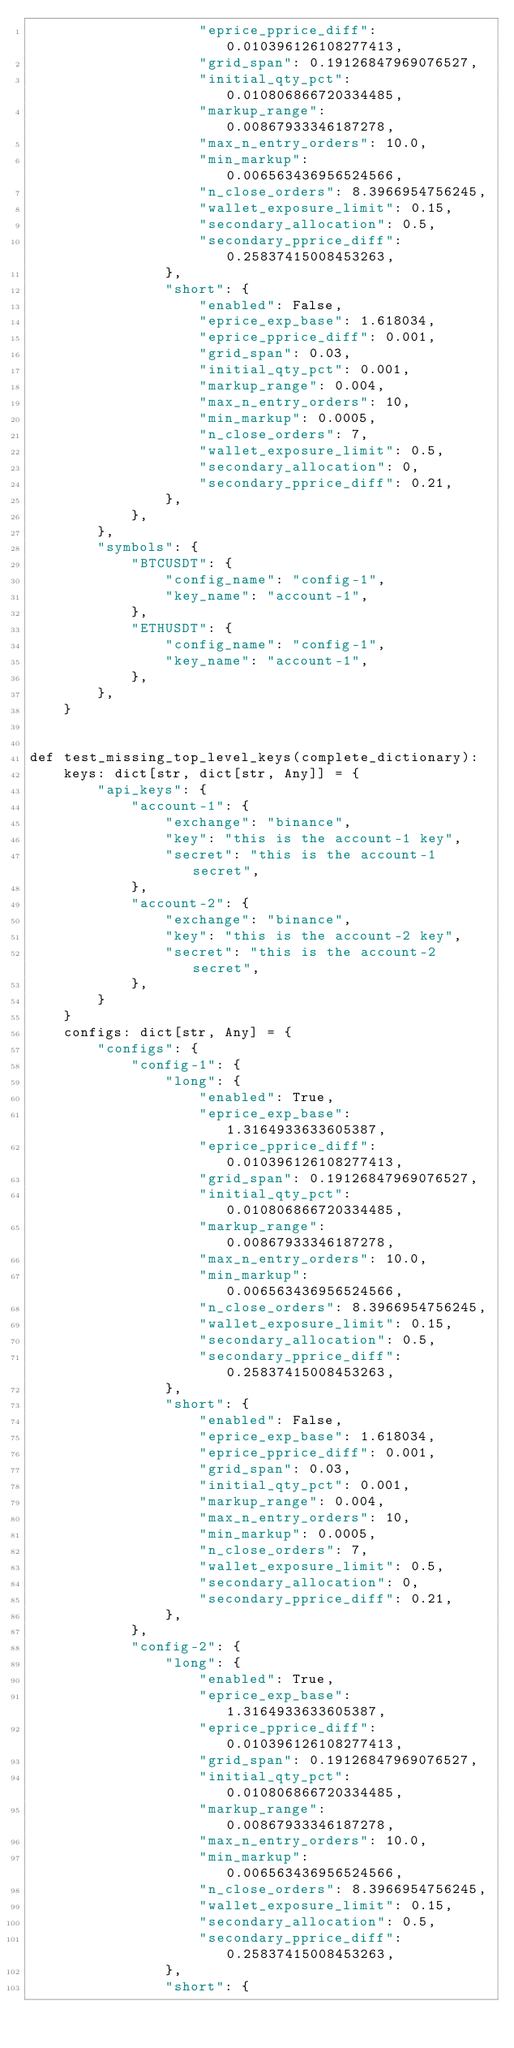<code> <loc_0><loc_0><loc_500><loc_500><_Python_>                    "eprice_pprice_diff": 0.010396126108277413,
                    "grid_span": 0.19126847969076527,
                    "initial_qty_pct": 0.010806866720334485,
                    "markup_range": 0.00867933346187278,
                    "max_n_entry_orders": 10.0,
                    "min_markup": 0.006563436956524566,
                    "n_close_orders": 8.3966954756245,
                    "wallet_exposure_limit": 0.15,
                    "secondary_allocation": 0.5,
                    "secondary_pprice_diff": 0.25837415008453263,
                },
                "short": {
                    "enabled": False,
                    "eprice_exp_base": 1.618034,
                    "eprice_pprice_diff": 0.001,
                    "grid_span": 0.03,
                    "initial_qty_pct": 0.001,
                    "markup_range": 0.004,
                    "max_n_entry_orders": 10,
                    "min_markup": 0.0005,
                    "n_close_orders": 7,
                    "wallet_exposure_limit": 0.5,
                    "secondary_allocation": 0,
                    "secondary_pprice_diff": 0.21,
                },
            },
        },
        "symbols": {
            "BTCUSDT": {
                "config_name": "config-1",
                "key_name": "account-1",
            },
            "ETHUSDT": {
                "config_name": "config-1",
                "key_name": "account-1",
            },
        },
    }


def test_missing_top_level_keys(complete_dictionary):
    keys: dict[str, dict[str, Any]] = {
        "api_keys": {
            "account-1": {
                "exchange": "binance",
                "key": "this is the account-1 key",
                "secret": "this is the account-1 secret",
            },
            "account-2": {
                "exchange": "binance",
                "key": "this is the account-2 key",
                "secret": "this is the account-2 secret",
            },
        }
    }
    configs: dict[str, Any] = {
        "configs": {
            "config-1": {
                "long": {
                    "enabled": True,
                    "eprice_exp_base": 1.3164933633605387,
                    "eprice_pprice_diff": 0.010396126108277413,
                    "grid_span": 0.19126847969076527,
                    "initial_qty_pct": 0.010806866720334485,
                    "markup_range": 0.00867933346187278,
                    "max_n_entry_orders": 10.0,
                    "min_markup": 0.006563436956524566,
                    "n_close_orders": 8.3966954756245,
                    "wallet_exposure_limit": 0.15,
                    "secondary_allocation": 0.5,
                    "secondary_pprice_diff": 0.25837415008453263,
                },
                "short": {
                    "enabled": False,
                    "eprice_exp_base": 1.618034,
                    "eprice_pprice_diff": 0.001,
                    "grid_span": 0.03,
                    "initial_qty_pct": 0.001,
                    "markup_range": 0.004,
                    "max_n_entry_orders": 10,
                    "min_markup": 0.0005,
                    "n_close_orders": 7,
                    "wallet_exposure_limit": 0.5,
                    "secondary_allocation": 0,
                    "secondary_pprice_diff": 0.21,
                },
            },
            "config-2": {
                "long": {
                    "enabled": True,
                    "eprice_exp_base": 1.3164933633605387,
                    "eprice_pprice_diff": 0.010396126108277413,
                    "grid_span": 0.19126847969076527,
                    "initial_qty_pct": 0.010806866720334485,
                    "markup_range": 0.00867933346187278,
                    "max_n_entry_orders": 10.0,
                    "min_markup": 0.006563436956524566,
                    "n_close_orders": 8.3966954756245,
                    "wallet_exposure_limit": 0.15,
                    "secondary_allocation": 0.5,
                    "secondary_pprice_diff": 0.25837415008453263,
                },
                "short": {</code> 